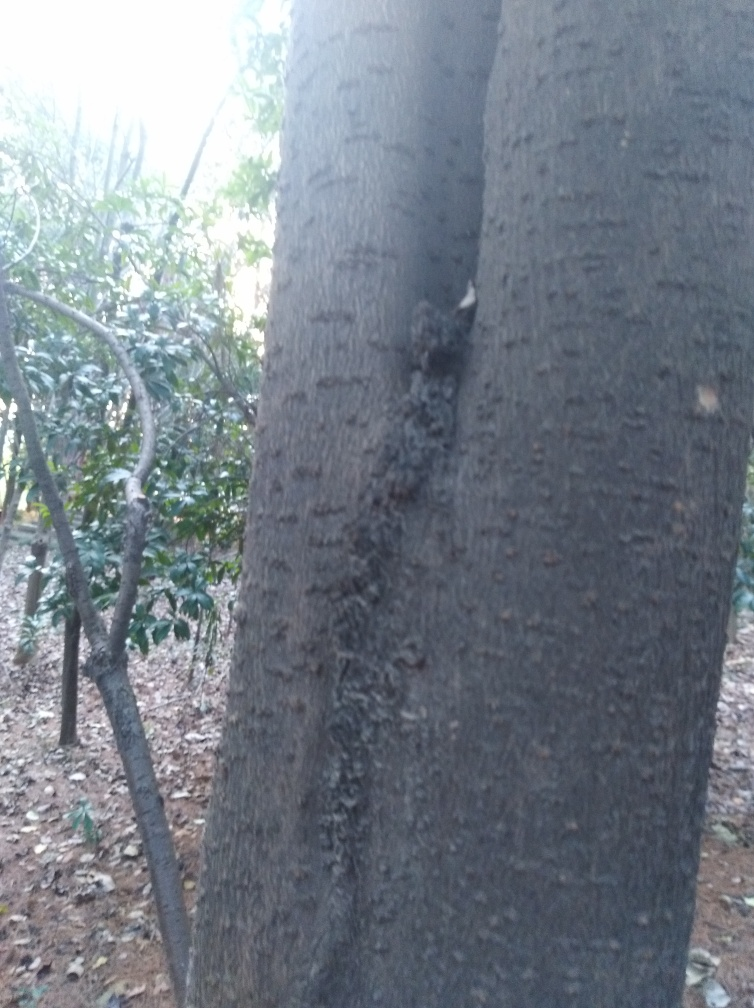What time of day does it look like this photo was taken? The photo appears to have been taken during twilight hours, where the light is diminishing, but it's not yet completely dark. The lack of shadows and the evenness of the light suggest that the sun is not directly shining on the scene. 